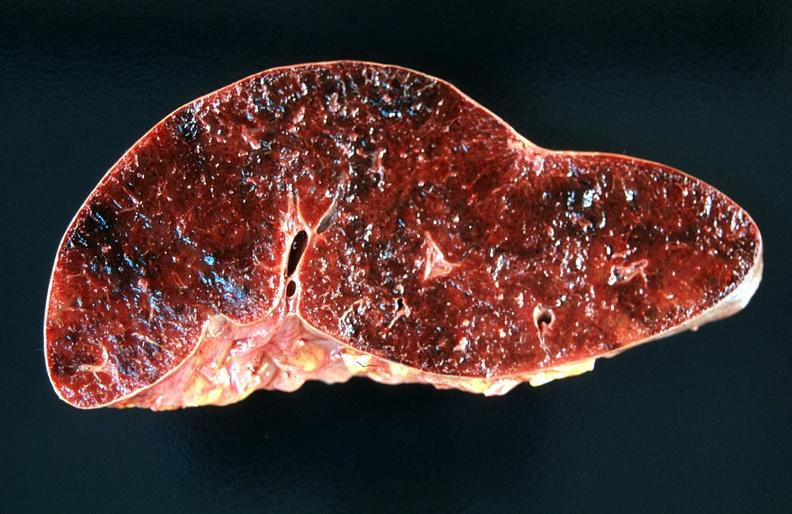does benign cystic teratoma show spleen, chronic congestion and hemorrhage?
Answer the question using a single word or phrase. No 